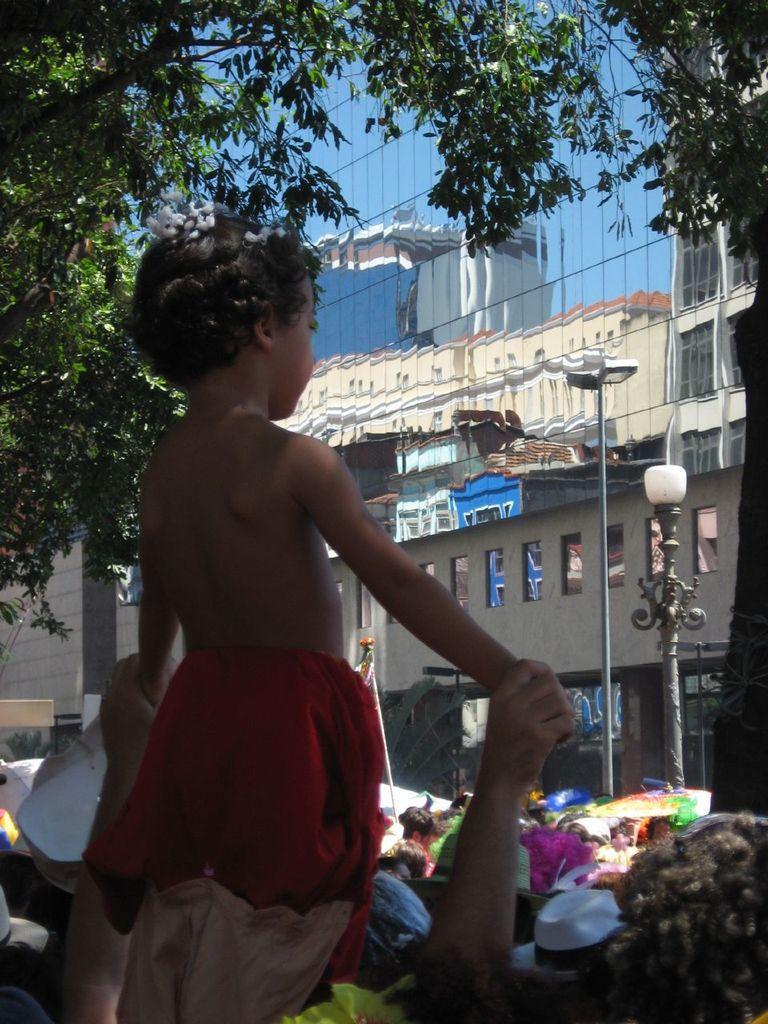Could you give a brief overview of what you see in this image? In this image on the left, there is a girl and person. In the middle there are many people, street lights, buildings, glass and trees. 